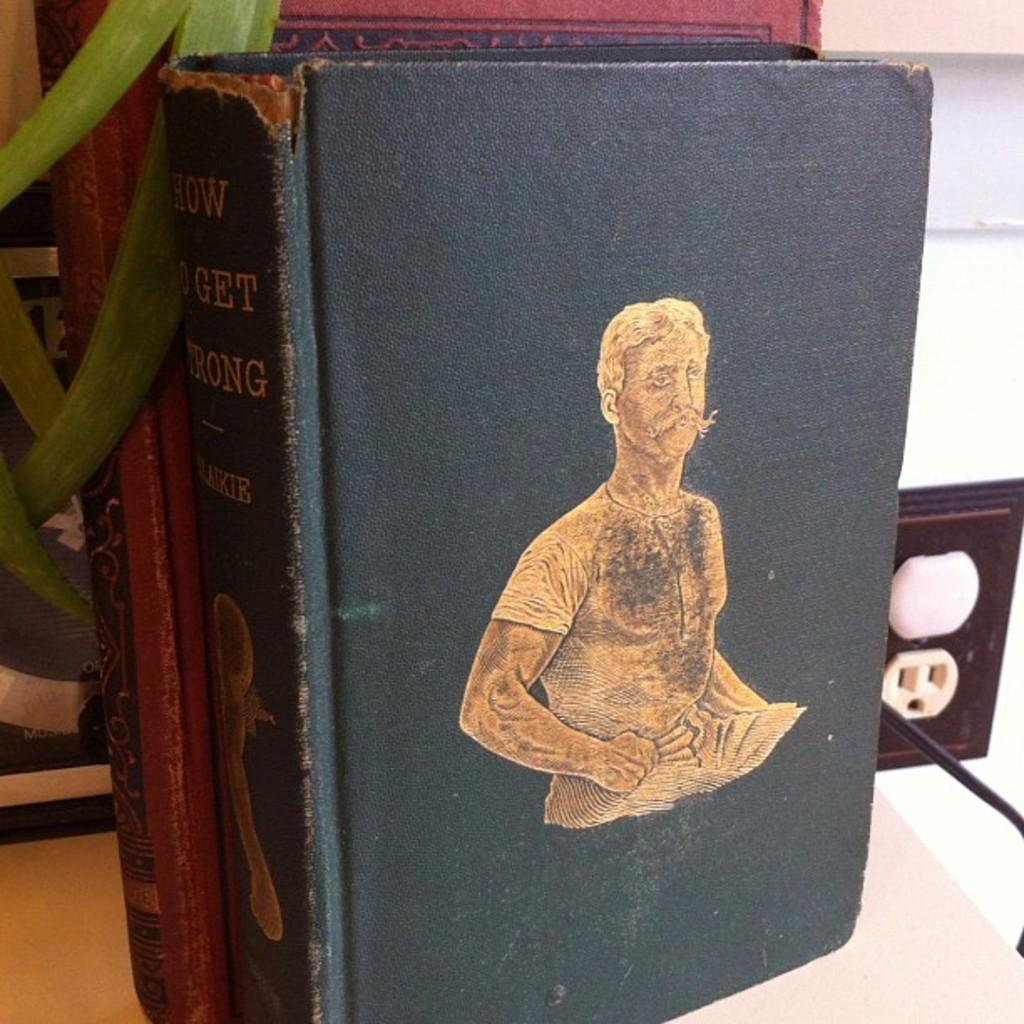<image>
Provide a brief description of the given image. A book titled "How to get strong." with a picture of a 1940's strong man. 